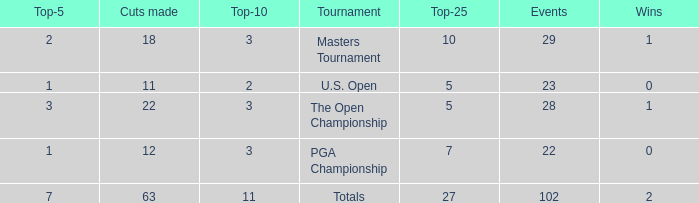How many cuts made for a player with 2 victories and fewer than 7 top 5s? None. Would you mind parsing the complete table? {'header': ['Top-5', 'Cuts made', 'Top-10', 'Tournament', 'Top-25', 'Events', 'Wins'], 'rows': [['2', '18', '3', 'Masters Tournament', '10', '29', '1'], ['1', '11', '2', 'U.S. Open', '5', '23', '0'], ['3', '22', '3', 'The Open Championship', '5', '28', '1'], ['1', '12', '3', 'PGA Championship', '7', '22', '0'], ['7', '63', '11', 'Totals', '27', '102', '2']]} 